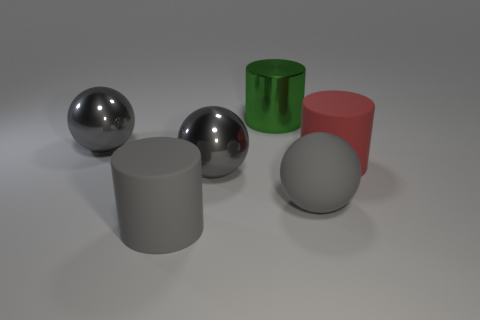How many gray spheres must be subtracted to get 2 gray spheres? 1 Subtract all big gray metal spheres. How many spheres are left? 1 Subtract 1 balls. How many balls are left? 2 Add 3 gray metal balls. How many objects exist? 9 Add 3 red objects. How many red objects are left? 4 Add 2 large gray things. How many large gray things exist? 6 Subtract 0 brown blocks. How many objects are left? 6 Subtract all blue spheres. Subtract all yellow cubes. How many spheres are left? 3 Subtract all red cylinders. Subtract all large gray shiny spheres. How many objects are left? 3 